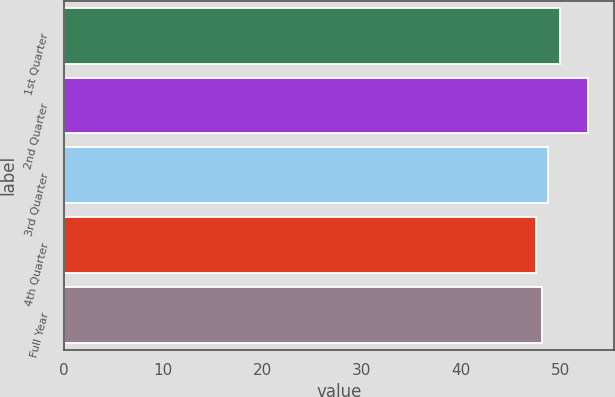<chart> <loc_0><loc_0><loc_500><loc_500><bar_chart><fcel>1st Quarter<fcel>2nd Quarter<fcel>3rd Quarter<fcel>4th Quarter<fcel>Full Year<nl><fcel>50<fcel>52.74<fcel>48.71<fcel>47.59<fcel>48.11<nl></chart> 